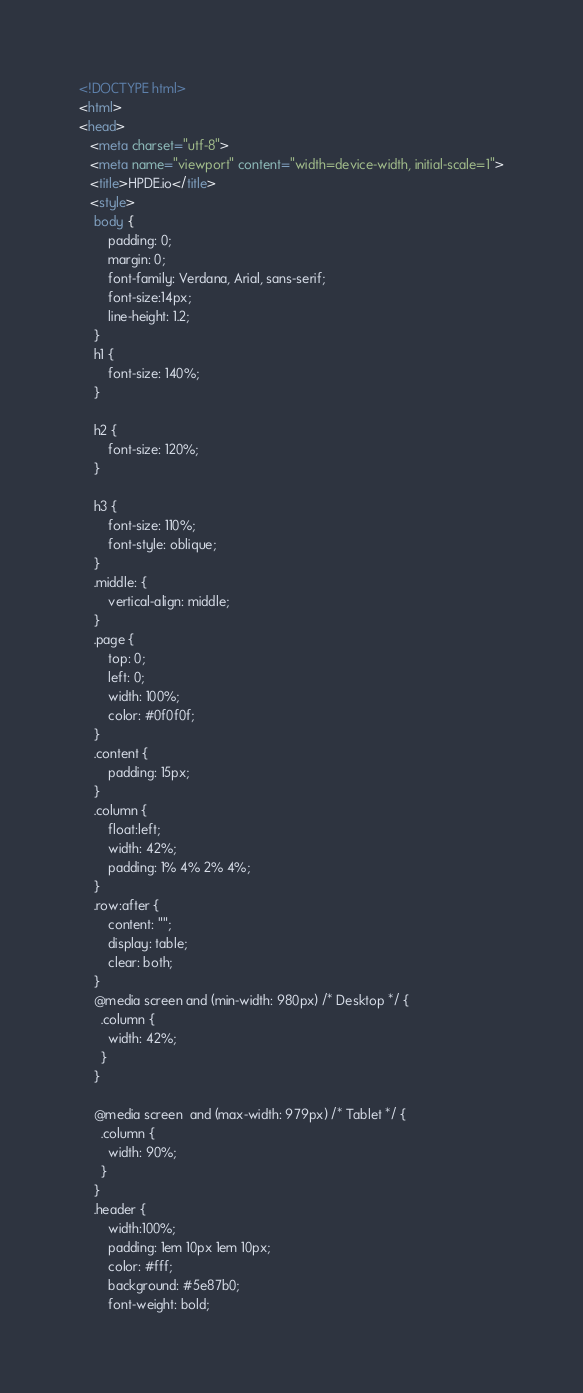<code> <loc_0><loc_0><loc_500><loc_500><_HTML_><!DOCTYPE html>
<html>
<head>
   <meta charset="utf-8">
   <meta name="viewport" content="width=device-width, initial-scale=1">
   <title>HPDE.io</title>
   <style>
	body {
		padding: 0;
		margin: 0;
		font-family: Verdana, Arial, sans-serif; 
		font-size:14px; 
		line-height: 1.2;
	}
	h1 {
		font-size: 140%;
	}

	h2 {
		font-size: 120%;
	}

	h3 {
		font-size: 110%;
		font-style: oblique;
	}
	.middle: {
		vertical-align: middle;
	}
	.page {
		top: 0;
		left: 0;
		width: 100%;
		color: #0f0f0f;
	}
	.content {
		padding: 15px;
	}
	.column {
		float:left;
		width: 42%;
		padding: 1% 4% 2% 4%;
	}
	.row:after {
		content: "";
		display: table;
		clear: both;
	}	
	@media screen and (min-width: 980px) /* Desktop */ {
	  .column {
		width: 42%;
	  }
	}

	@media screen  and (max-width: 979px) /* Tablet */ {
	  .column {
		width: 90%;
	  }
	}
	.header {
		width:100%;
		padding: 1em 10px 1em 10px;
		color: #fff;
		background: #5e87b0;
		font-weight: bold;</code> 